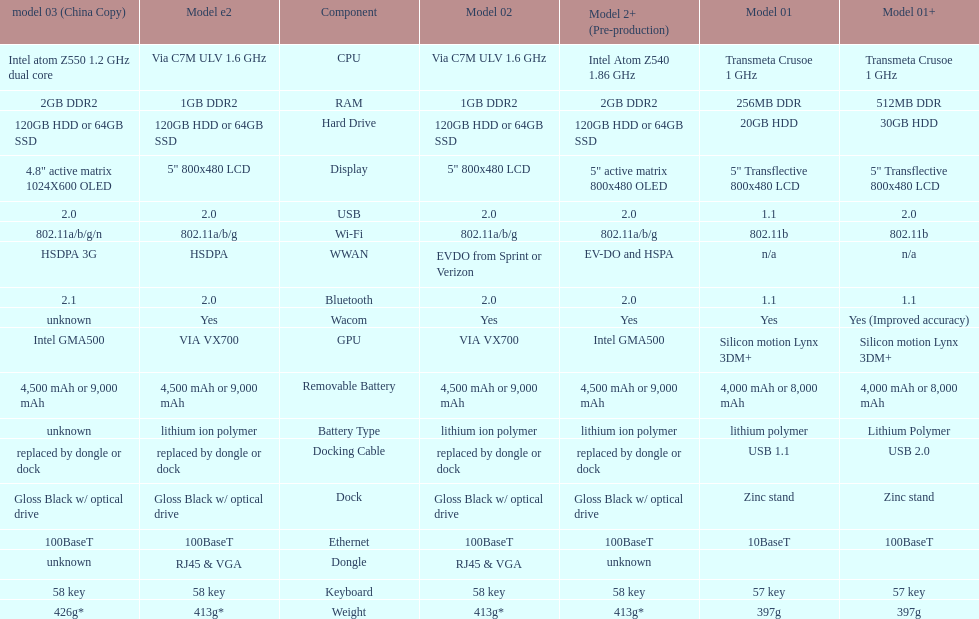Can you parse all the data within this table? {'header': ['model 03 (China Copy)', 'Model e2', 'Component', 'Model 02', 'Model 2+ (Pre-production)', 'Model 01', 'Model 01+'], 'rows': [['Intel atom Z550 1.2\xa0GHz dual core', 'Via C7M ULV 1.6\xa0GHz', 'CPU', 'Via C7M ULV 1.6\xa0GHz', 'Intel Atom Z540 1.86\xa0GHz', 'Transmeta Crusoe 1\xa0GHz', 'Transmeta Crusoe 1\xa0GHz'], ['2GB DDR2', '1GB DDR2', 'RAM', '1GB DDR2', '2GB DDR2', '256MB DDR', '512MB DDR'], ['120GB HDD or 64GB SSD', '120GB HDD or 64GB SSD', 'Hard Drive', '120GB HDD or 64GB SSD', '120GB HDD or 64GB SSD', '20GB HDD', '30GB HDD'], ['4.8" active matrix 1024X600 OLED', '5" 800x480 LCD', 'Display', '5" 800x480 LCD', '5" active matrix 800x480 OLED', '5" Transflective 800x480 LCD', '5" Transflective 800x480 LCD'], ['2.0', '2.0', 'USB', '2.0', '2.0', '1.1', '2.0'], ['802.11a/b/g/n', '802.11a/b/g', 'Wi-Fi', '802.11a/b/g', '802.11a/b/g', '802.11b', '802.11b'], ['HSDPA 3G', 'HSDPA', 'WWAN', 'EVDO from Sprint or Verizon', 'EV-DO and HSPA', 'n/a', 'n/a'], ['2.1', '2.0', 'Bluetooth', '2.0', '2.0', '1.1', '1.1'], ['unknown', 'Yes', 'Wacom', 'Yes', 'Yes', 'Yes', 'Yes (Improved accuracy)'], ['Intel GMA500', 'VIA VX700', 'GPU', 'VIA VX700', 'Intel GMA500', 'Silicon motion Lynx 3DM+', 'Silicon motion Lynx 3DM+'], ['4,500 mAh or 9,000 mAh', '4,500 mAh or 9,000 mAh', 'Removable Battery', '4,500 mAh or 9,000 mAh', '4,500 mAh or 9,000 mAh', '4,000 mAh or 8,000 mAh', '4,000 mAh or 8,000 mAh'], ['unknown', 'lithium ion polymer', 'Battery Type', 'lithium ion polymer', 'lithium ion polymer', 'lithium polymer', 'Lithium Polymer'], ['replaced by dongle or dock', 'replaced by dongle or dock', 'Docking Cable', 'replaced by dongle or dock', 'replaced by dongle or dock', 'USB 1.1', 'USB 2.0'], ['Gloss Black w/ optical drive', 'Gloss Black w/ optical drive', 'Dock', 'Gloss Black w/ optical drive', 'Gloss Black w/ optical drive', 'Zinc stand', 'Zinc stand'], ['100BaseT', '100BaseT', 'Ethernet', '100BaseT', '100BaseT', '10BaseT', '100BaseT'], ['unknown', 'RJ45 & VGA', 'Dongle', 'RJ45 & VGA', 'unknown', '', ''], ['58 key', '58 key', 'Keyboard', '58 key', '58 key', '57 key', '57 key'], ['426g*', '413g*', 'Weight', '413g*', '413g*', '397g', '397g']]} Which model weighs the most, according to the table? Model 03 (china copy). 